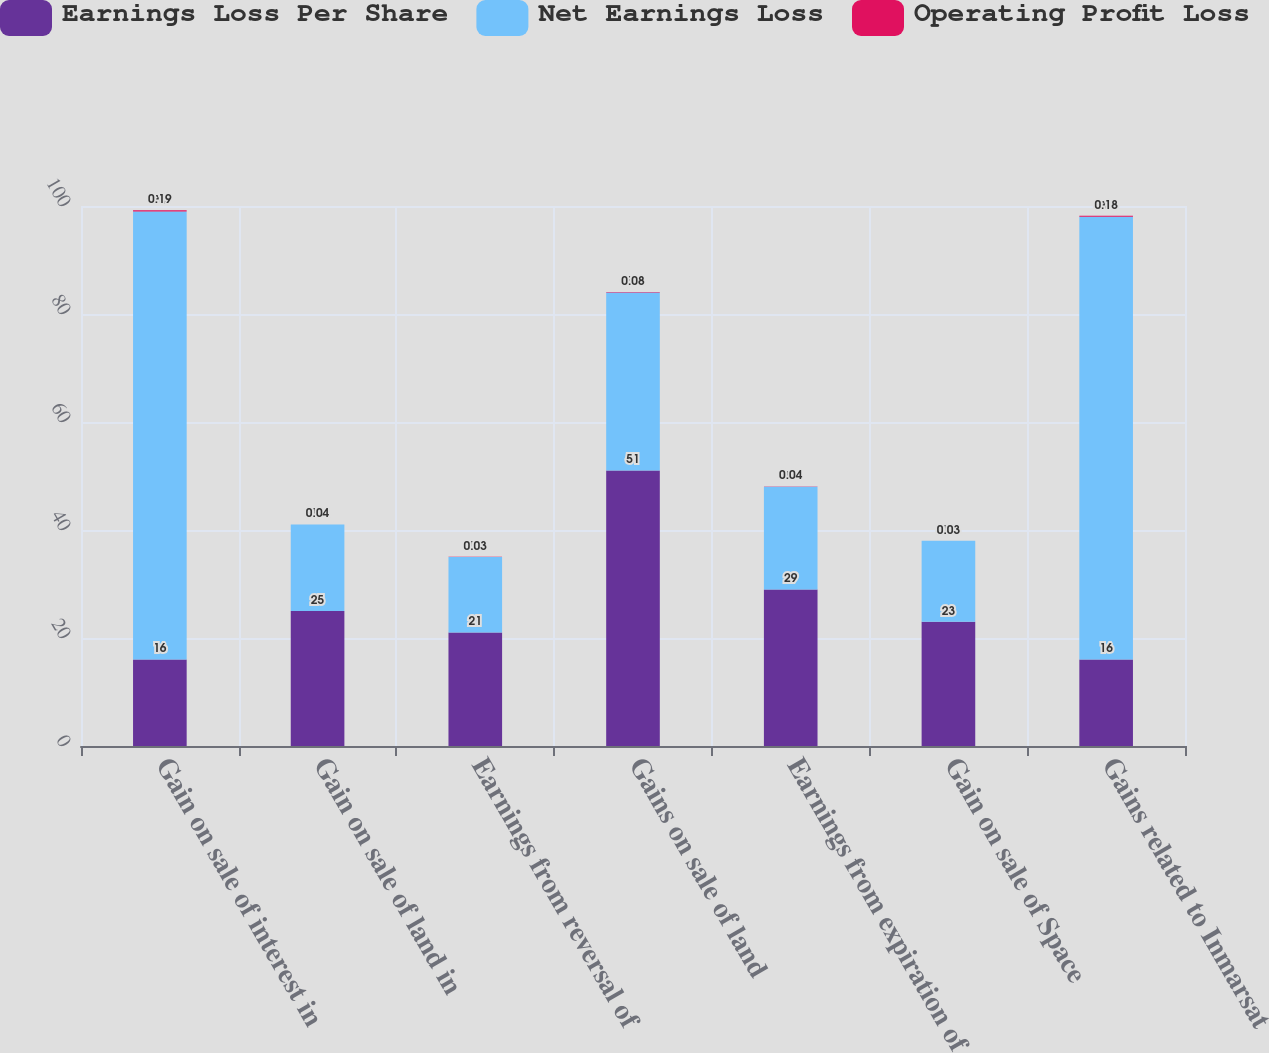Convert chart to OTSL. <chart><loc_0><loc_0><loc_500><loc_500><stacked_bar_chart><ecel><fcel>Gain on sale of interest in<fcel>Gain on sale of land in<fcel>Earnings from reversal of<fcel>Gains on sale of land<fcel>Earnings from expiration of<fcel>Gain on sale of Space<fcel>Gains related to Inmarsat<nl><fcel>Earnings Loss Per Share<fcel>16<fcel>25<fcel>21<fcel>51<fcel>29<fcel>23<fcel>16<nl><fcel>Net Earnings Loss<fcel>83<fcel>16<fcel>14<fcel>33<fcel>19<fcel>15<fcel>82<nl><fcel>Operating Profit Loss<fcel>0.19<fcel>0.04<fcel>0.03<fcel>0.08<fcel>0.04<fcel>0.03<fcel>0.18<nl></chart> 